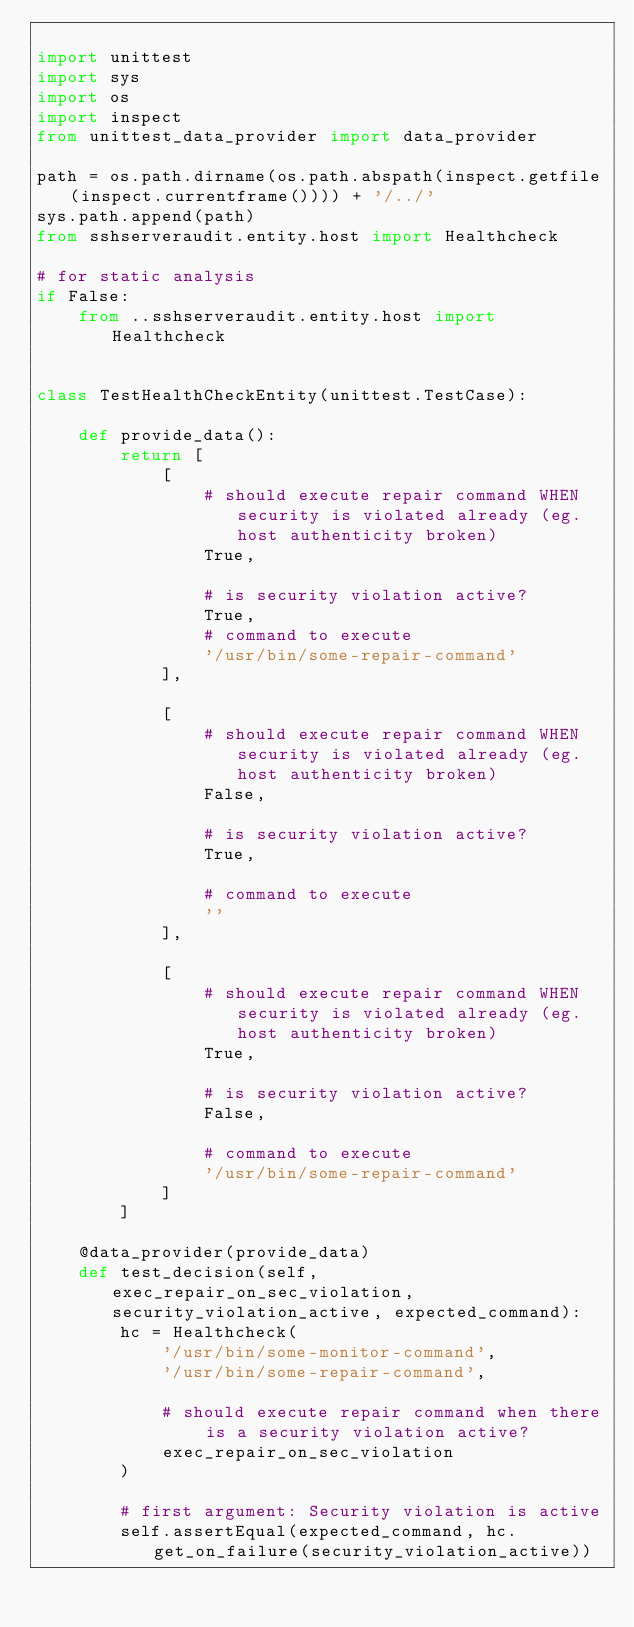Convert code to text. <code><loc_0><loc_0><loc_500><loc_500><_Python_>
import unittest
import sys
import os
import inspect
from unittest_data_provider import data_provider

path = os.path.dirname(os.path.abspath(inspect.getfile(inspect.currentframe()))) + '/../'
sys.path.append(path)
from sshserveraudit.entity.host import Healthcheck

# for static analysis
if False:
    from ..sshserveraudit.entity.host import Healthcheck


class TestHealthCheckEntity(unittest.TestCase):

    def provide_data():
        return [
            [
                # should execute repair command WHEN security is violated already (eg. host authenticity broken)
                True,

                # is security violation active?
                True,
                # command to execute
                '/usr/bin/some-repair-command'
            ],

            [
                # should execute repair command WHEN security is violated already (eg. host authenticity broken)
                False,

                # is security violation active?
                True,

                # command to execute
                ''
            ],

            [
                # should execute repair command WHEN security is violated already (eg. host authenticity broken)
                True,

                # is security violation active?
                False,

                # command to execute
                '/usr/bin/some-repair-command'
            ]
        ]

    @data_provider(provide_data)
    def test_decision(self, exec_repair_on_sec_violation, security_violation_active, expected_command):
        hc = Healthcheck(
            '/usr/bin/some-monitor-command',
            '/usr/bin/some-repair-command',

            # should execute repair command when there is a security violation active?
            exec_repair_on_sec_violation
        )

        # first argument: Security violation is active
        self.assertEqual(expected_command, hc.get_on_failure(security_violation_active))
</code> 